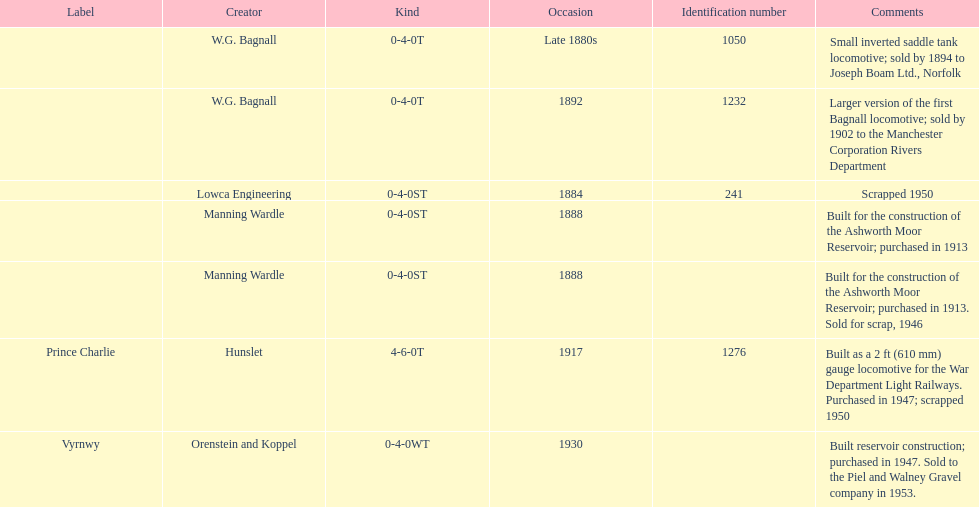List each of the builder's that had a locomotive scrapped. Lowca Engineering, Manning Wardle, Hunslet. 